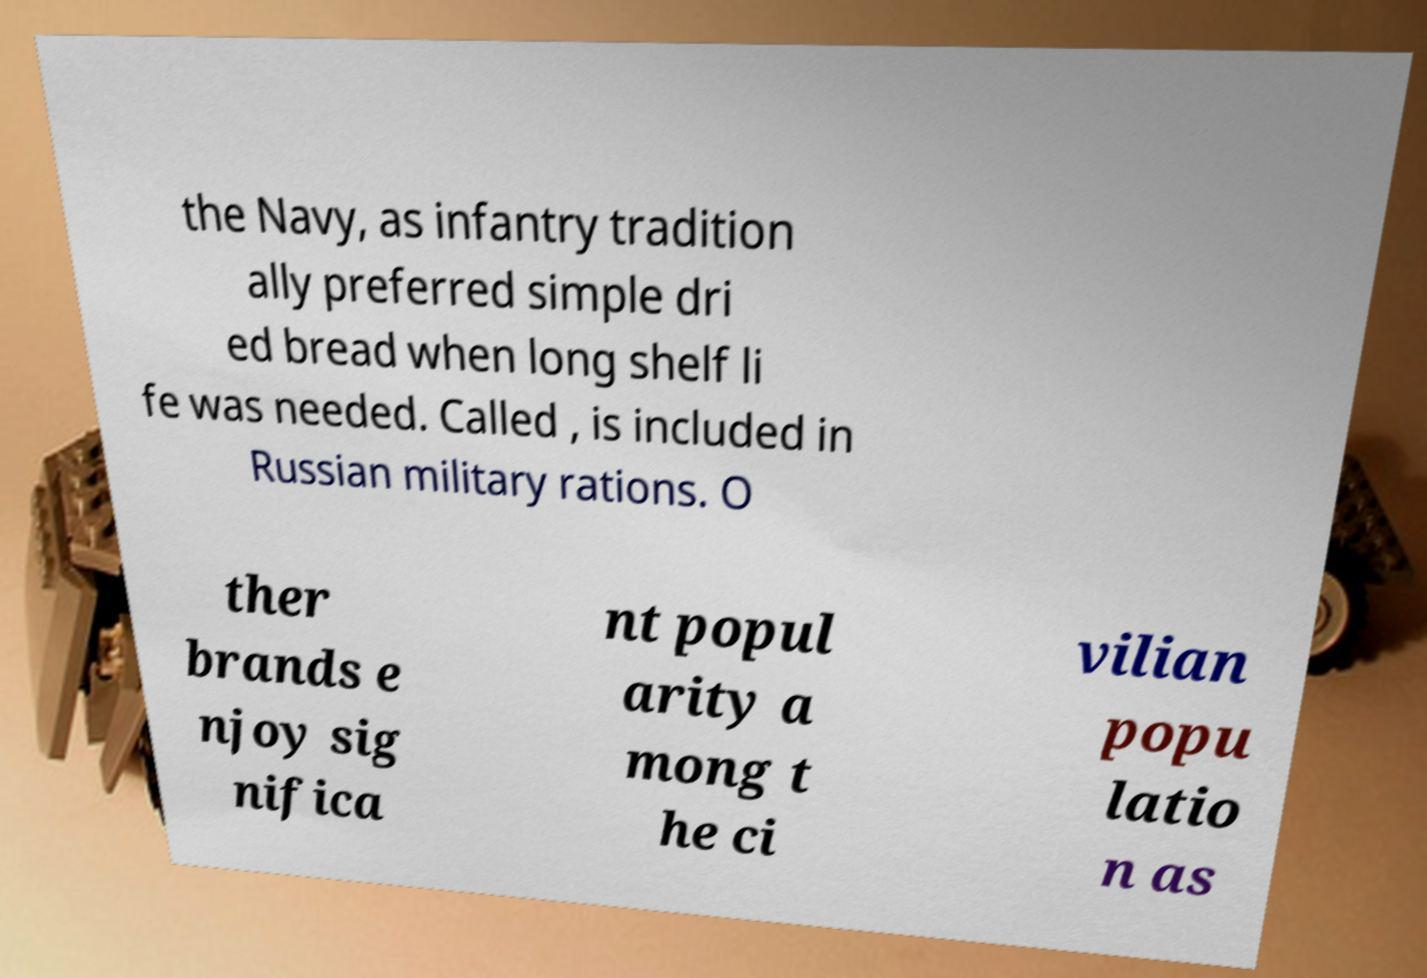Could you extract and type out the text from this image? the Navy, as infantry tradition ally preferred simple dri ed bread when long shelf li fe was needed. Called , is included in Russian military rations. O ther brands e njoy sig nifica nt popul arity a mong t he ci vilian popu latio n as 